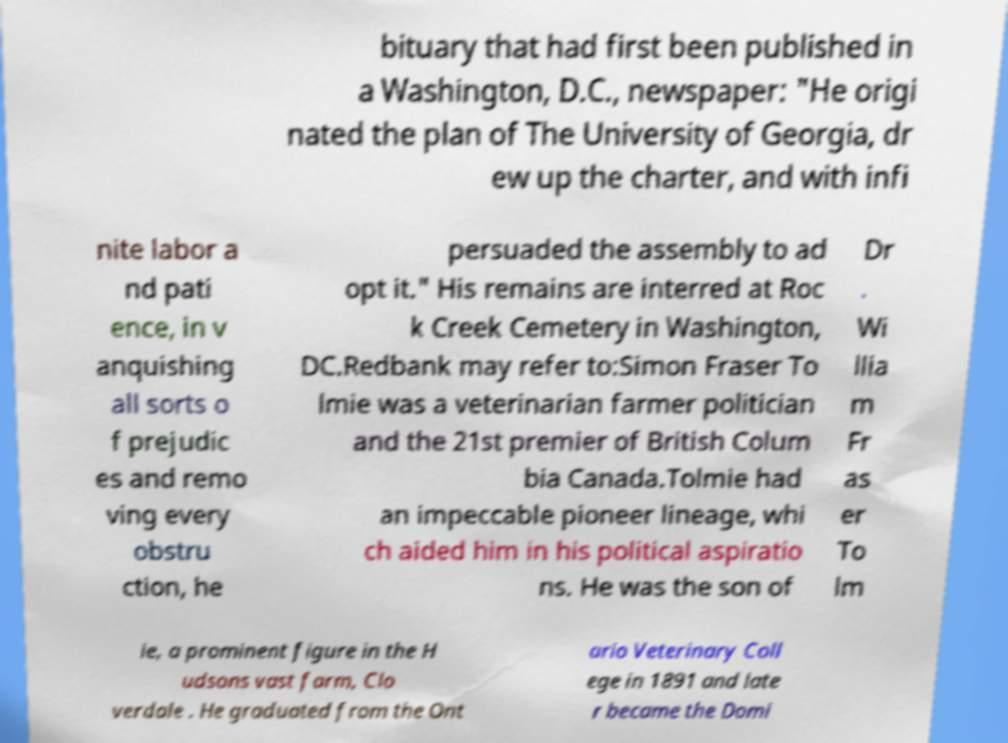Please identify and transcribe the text found in this image. bituary that had first been published in a Washington, D.C., newspaper: "He origi nated the plan of The University of Georgia, dr ew up the charter, and with infi nite labor a nd pati ence, in v anquishing all sorts o f prejudic es and remo ving every obstru ction, he persuaded the assembly to ad opt it." His remains are interred at Roc k Creek Cemetery in Washington, DC.Redbank may refer to:Simon Fraser To lmie was a veterinarian farmer politician and the 21st premier of British Colum bia Canada.Tolmie had an impeccable pioneer lineage, whi ch aided him in his political aspiratio ns. He was the son of Dr . Wi llia m Fr as er To lm ie, a prominent figure in the H udsons vast farm, Clo verdale . He graduated from the Ont ario Veterinary Coll ege in 1891 and late r became the Domi 